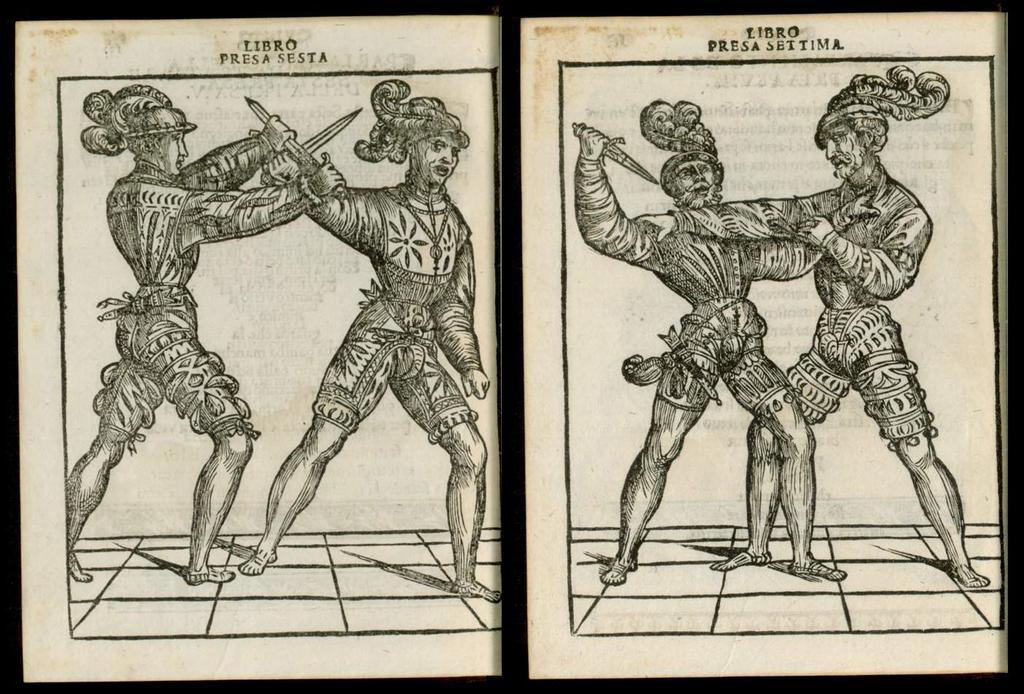Describe this image in one or two sentences. In this picture we have two frames where these two frames are belonging to some art of fighting with sword in their hand and this people are wearing costumes. 